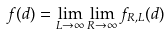<formula> <loc_0><loc_0><loc_500><loc_500>f ( d ) = \lim _ { L \to \infty } \lim _ { R \to \infty } f _ { R , L } ( d )</formula> 